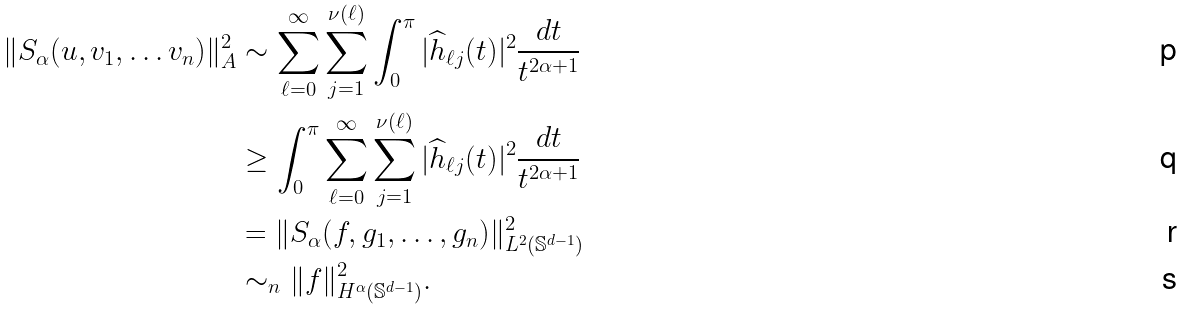<formula> <loc_0><loc_0><loc_500><loc_500>\| S _ { \alpha } ( u , v _ { 1 } , \dots v _ { n } ) \| _ { A } ^ { 2 } & \sim \sum _ { \ell = 0 } ^ { \infty } \sum _ { j = 1 } ^ { \nu ( \ell ) } \int _ { 0 } ^ { \pi } | \widehat { h } _ { \ell j } ( t ) | ^ { 2 } \frac { d t } { t ^ { 2 \alpha + 1 } } \\ & \geq \int _ { 0 } ^ { \pi } \sum _ { \ell = 0 } ^ { \infty } \sum _ { j = 1 } ^ { \nu ( \ell ) } | \widehat { h } _ { \ell j } ( t ) | ^ { 2 } \frac { d t } { t ^ { 2 \alpha + 1 } } \\ & = \| S _ { \alpha } ( f , g _ { 1 } , \dots , g _ { n } ) \| _ { L ^ { 2 } ( \mathbb { S } ^ { d - 1 } ) } ^ { 2 } \\ & \sim _ { n } \| f \| _ { H ^ { \alpha } ( \mathbb { S } ^ { d - 1 } ) } ^ { 2 } .</formula> 